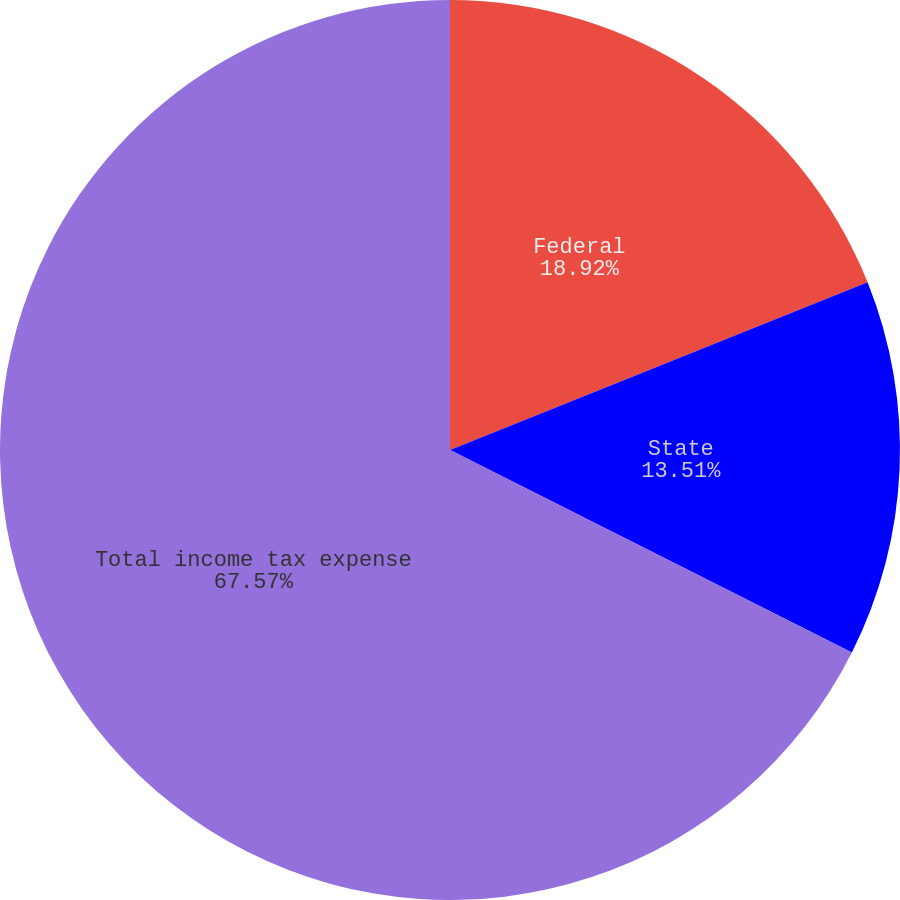Convert chart. <chart><loc_0><loc_0><loc_500><loc_500><pie_chart><fcel>Federal<fcel>State<fcel>Total income tax expense<nl><fcel>18.92%<fcel>13.51%<fcel>67.57%<nl></chart> 